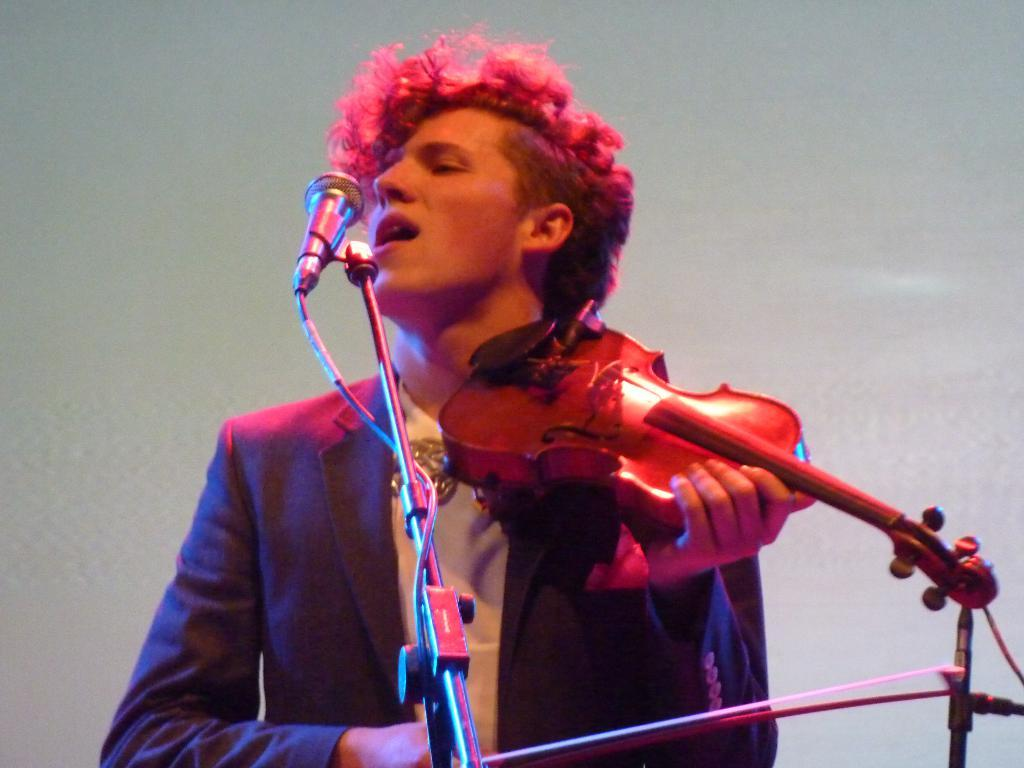Who is the person in the image? There is a man in the image. What is the man wearing? The man is wearing a suit. What is the man doing in the image? The man is playing a guitar. What is in front of the man? There is a stand and a microphone in front of the man. What is the color of the background in the image? The background of the image is white. What type of beef can be seen cooking on the stand in the image? There is no beef present in the image; the stand is being used to hold the guitar. Can you see a zipper on the man's suit in the image? There is no mention of a zipper on the man's suit in the provided facts, so it cannot be determined from the image. 